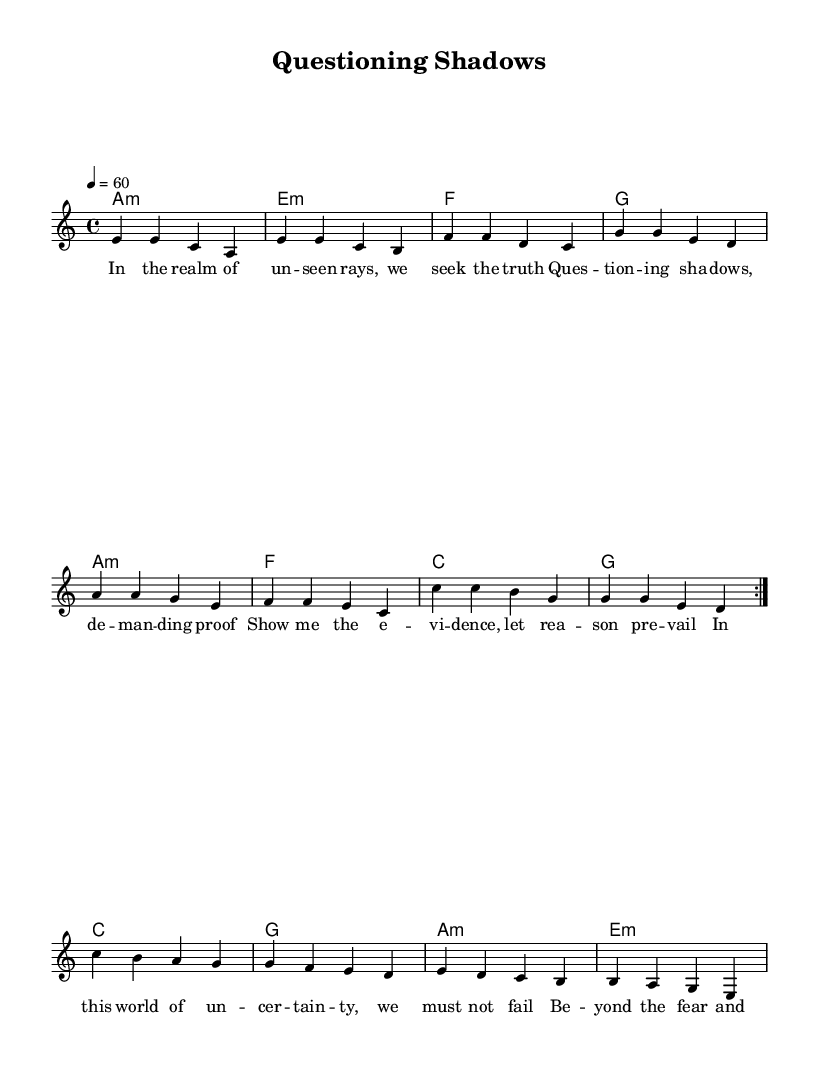What is the key signature of this music? The key signature is A minor, which has no sharps or flats because it is the relative minor of C major.
Answer: A minor What is the time signature of this music? The time signature is 4/4, indicating there are four beats in each measure and a quarter note gets one beat.
Answer: 4/4 What is the tempo marking? The tempo marking is 60 beats per minute, indicating a slow pace for the piece.
Answer: 60 How many measures are repeated in the melody? There are 2 measures repeated in the melody, as indicated by the volta markings that specify the repetition of the section.
Answer: 2 What is the primary theme explored in the lyrics? The primary theme explored in the lyrics is skepticism, as it calls for questioning beliefs and seeking evidence in uncertain situations.
Answer: Skepticism What chord is used at the start of each section in the harmonies? The chord used at the start of each section in the harmonies is A minor, as evidenced by the first chord in the chord progression.
Answer: A minor What type of song structure is primarily represented in this music? The song structure is predominantly a verse structure, as only lyrics for a single verse are provided without a chorus or additional sections.
Answer: Verse 